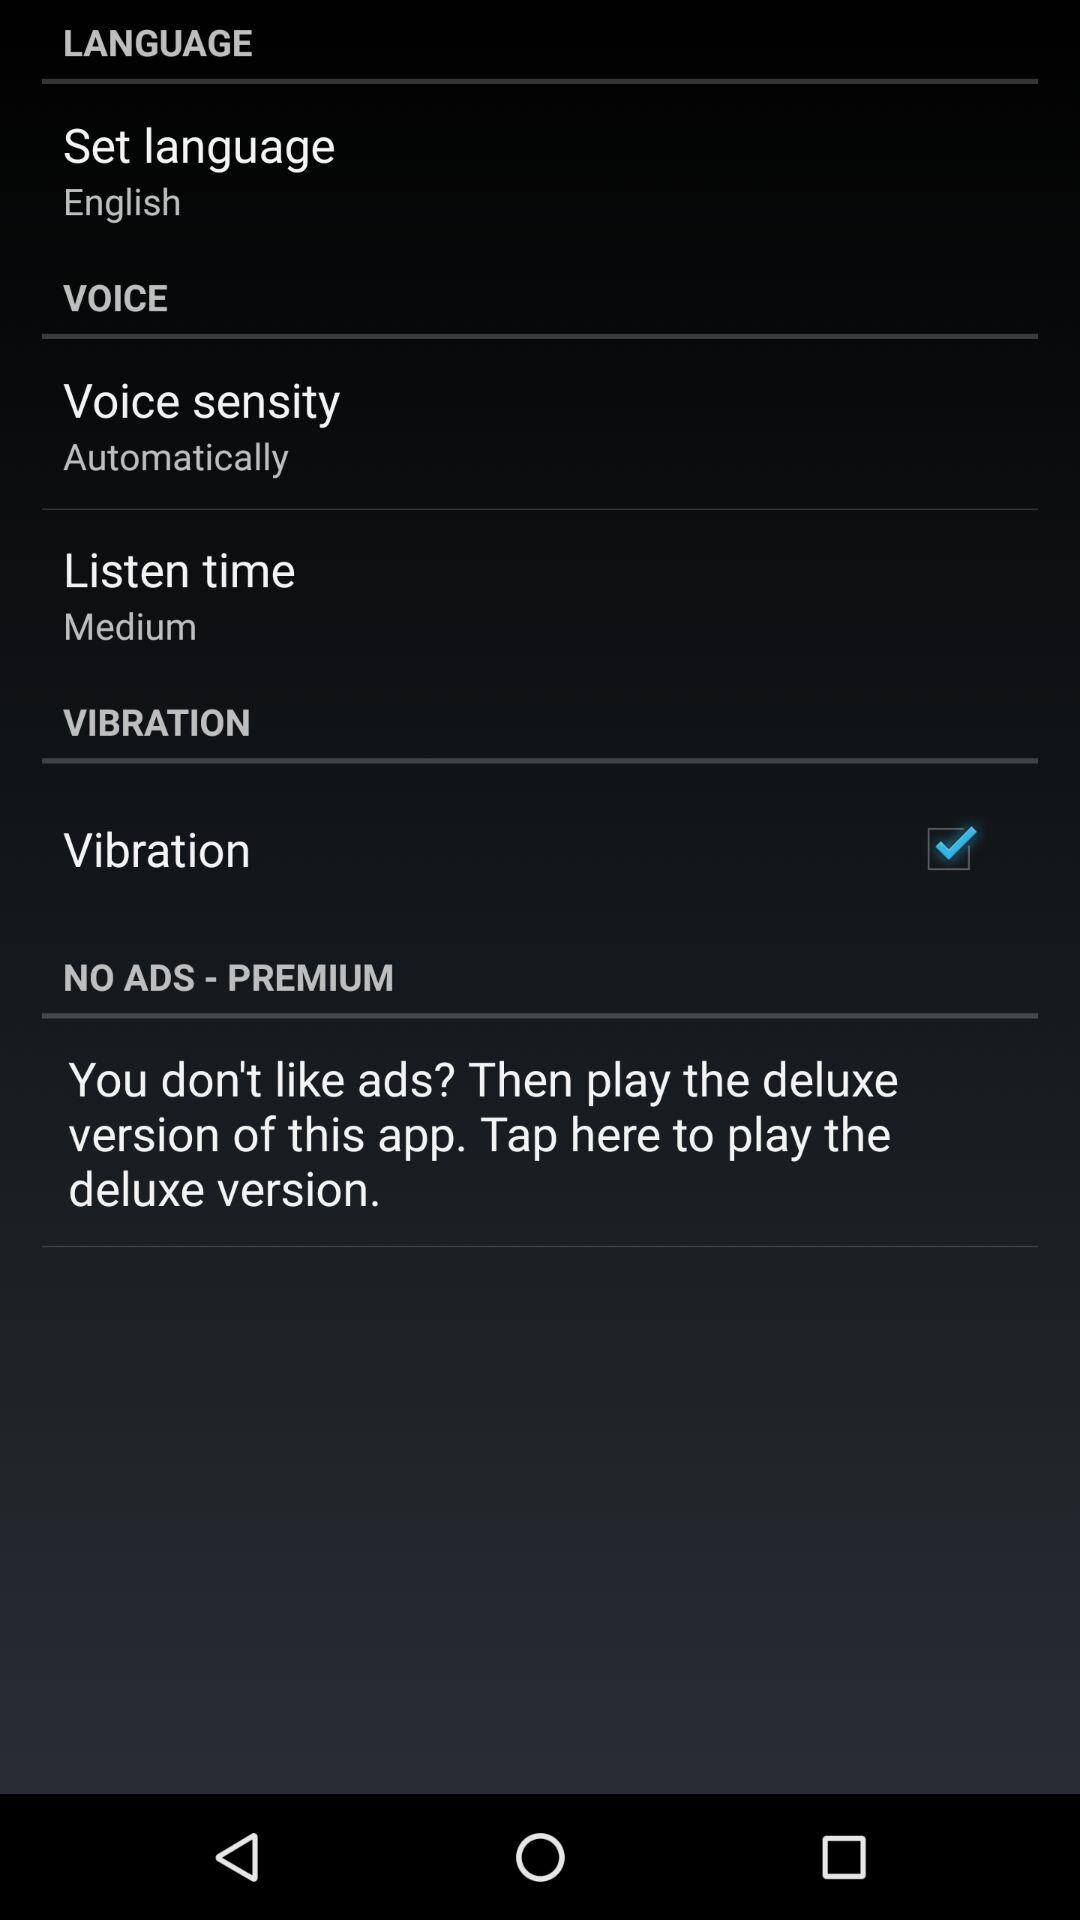What is the status of "Vibration"? The status of "Vibration" is "on". 